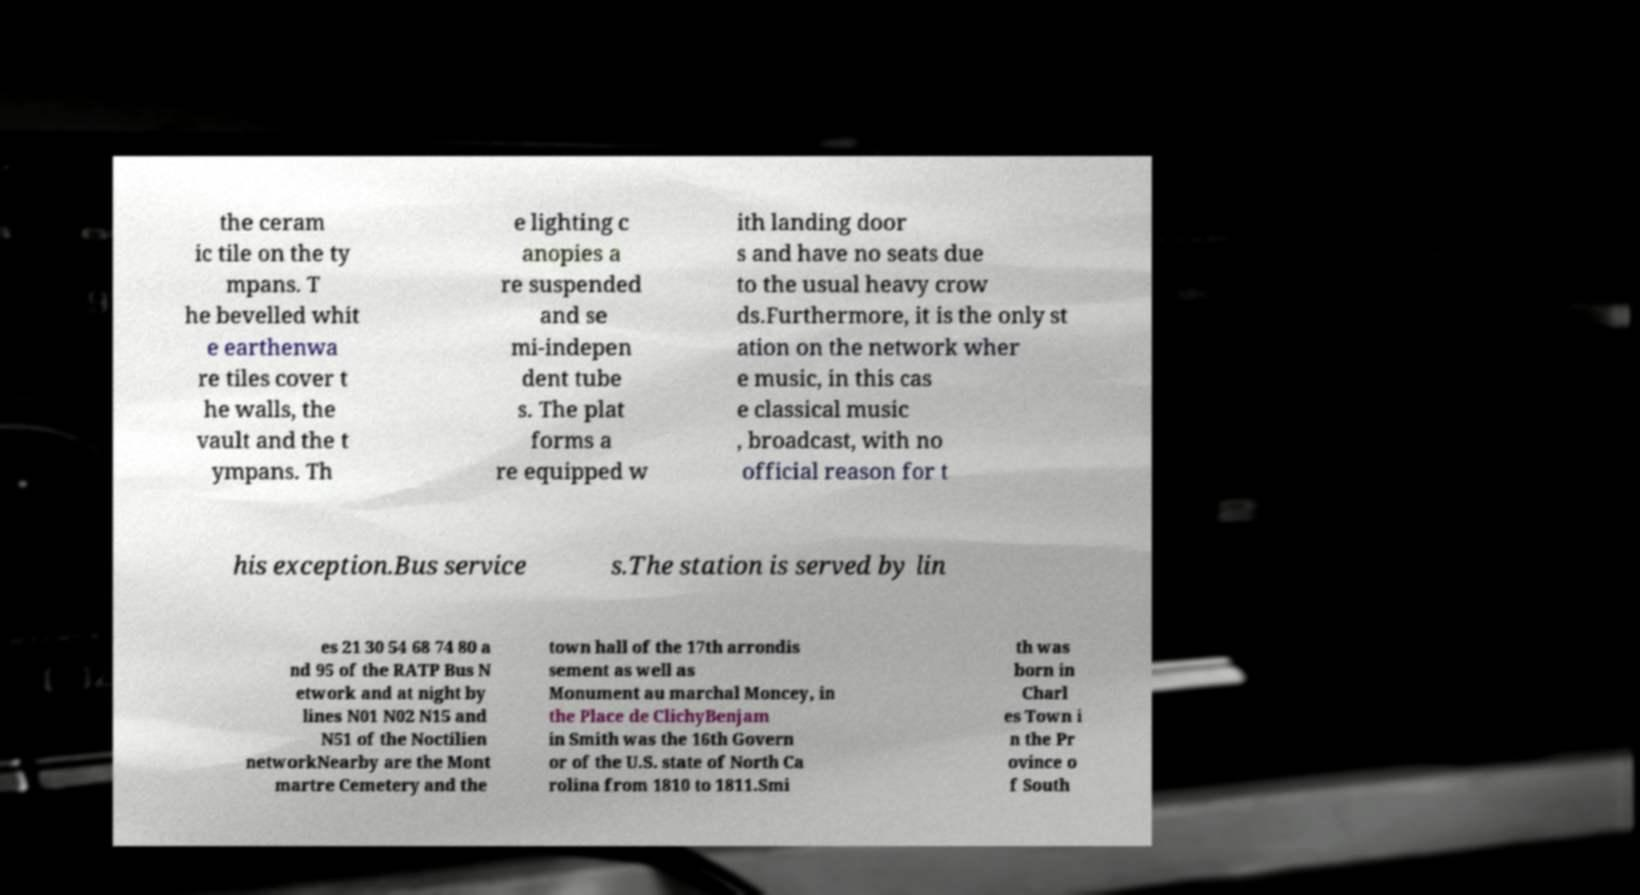Can you accurately transcribe the text from the provided image for me? the ceram ic tile on the ty mpans. T he bevelled whit e earthenwa re tiles cover t he walls, the vault and the t ympans. Th e lighting c anopies a re suspended and se mi-indepen dent tube s. The plat forms a re equipped w ith landing door s and have no seats due to the usual heavy crow ds.Furthermore, it is the only st ation on the network wher e music, in this cas e classical music , broadcast, with no official reason for t his exception.Bus service s.The station is served by lin es 21 30 54 68 74 80 a nd 95 of the RATP Bus N etwork and at night by lines N01 N02 N15 and N51 of the Noctilien networkNearby are the Mont martre Cemetery and the town hall of the 17th arrondis sement as well as Monument au marchal Moncey, in the Place de ClichyBenjam in Smith was the 16th Govern or of the U.S. state of North Ca rolina from 1810 to 1811.Smi th was born in Charl es Town i n the Pr ovince o f South 